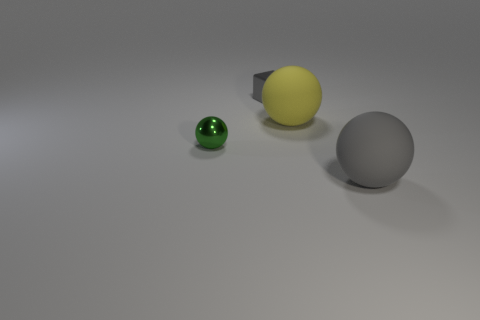There is a big object that is the same color as the small shiny cube; what is its material?
Give a very brief answer. Rubber. Is the color of the small ball the same as the tiny metal block?
Your response must be concise. No. How many other things are the same color as the small metallic sphere?
Your response must be concise. 0. Are there fewer big spheres behind the big yellow object than balls that are behind the small green thing?
Your answer should be compact. Yes. There is a small shiny object that is the same shape as the yellow rubber object; what is its color?
Make the answer very short. Green. How many matte objects are both behind the tiny metallic sphere and in front of the small green metal object?
Give a very brief answer. 0. Is the number of rubber things that are to the right of the gray matte sphere greater than the number of gray cubes that are to the left of the green metallic ball?
Provide a succinct answer. No. How big is the metallic cube?
Your answer should be very brief. Small. Are there any other tiny gray metal objects that have the same shape as the small gray shiny thing?
Keep it short and to the point. No. Does the small gray thing have the same shape as the rubber object that is behind the small ball?
Make the answer very short. No. 